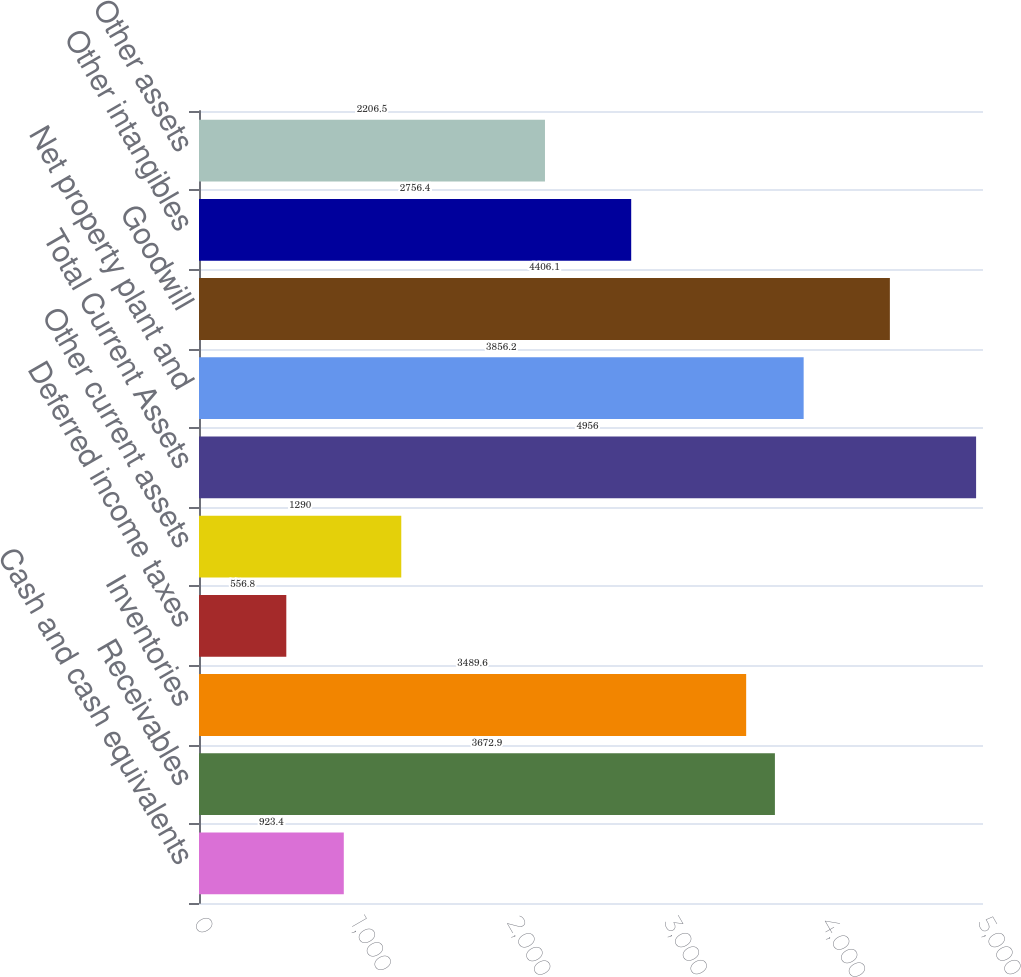Convert chart to OTSL. <chart><loc_0><loc_0><loc_500><loc_500><bar_chart><fcel>Cash and cash equivalents<fcel>Receivables<fcel>Inventories<fcel>Deferred income taxes<fcel>Other current assets<fcel>Total Current Assets<fcel>Net property plant and<fcel>Goodwill<fcel>Other intangibles<fcel>Other assets<nl><fcel>923.4<fcel>3672.9<fcel>3489.6<fcel>556.8<fcel>1290<fcel>4956<fcel>3856.2<fcel>4406.1<fcel>2756.4<fcel>2206.5<nl></chart> 